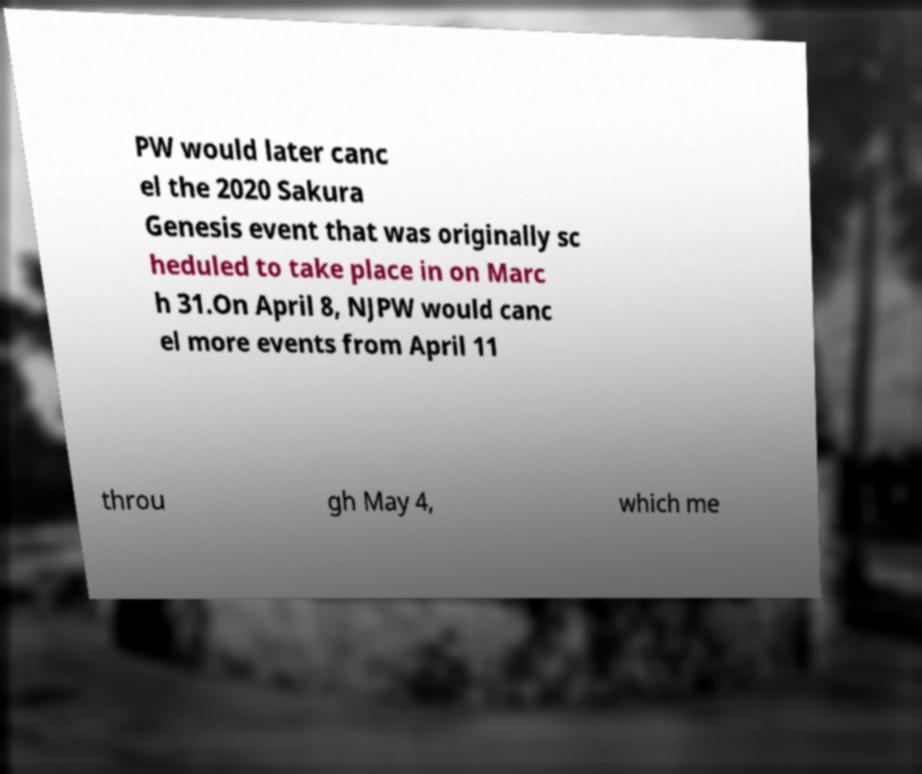Please identify and transcribe the text found in this image. PW would later canc el the 2020 Sakura Genesis event that was originally sc heduled to take place in on Marc h 31.On April 8, NJPW would canc el more events from April 11 throu gh May 4, which me 